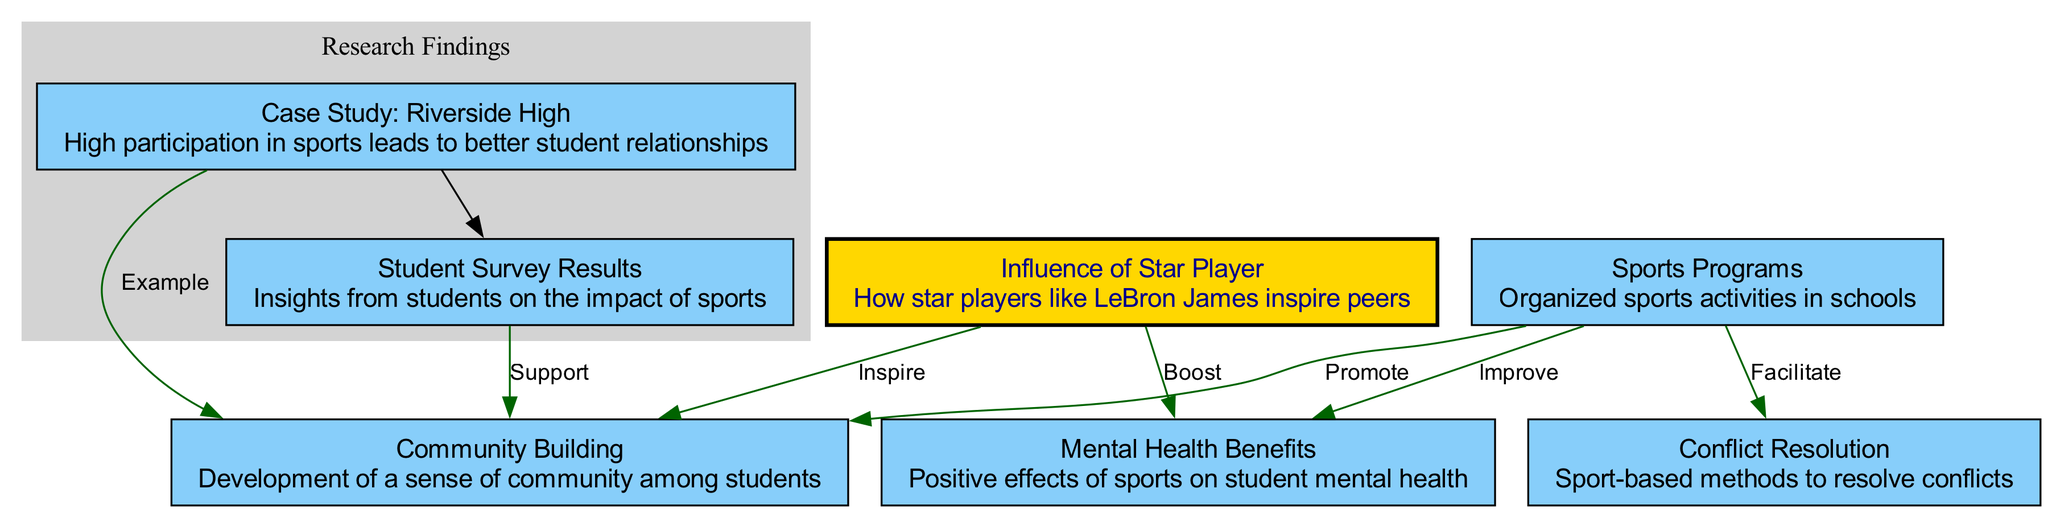What is one of the main benefits of sports programs in schools? Sports programs improve mental health among students, as indicated by the arrow connecting "Sports Programs" to "Mental Health Benefits" labeled "Improve."
Answer: Improve How does the case study of Riverside High relate to community building? The case study shows that high participation in sports at Riverside High serves as an example of promoting community building, as indicated by the direct connection labeled "Example."
Answer: Example What type of impact do student survey results have on community building? Student survey results support the development of community building, as shown by the edge labeled "Support" connecting "Student Survey Results" to "Community Building."
Answer: Support Which node highlights the influence of star players? The node labeled "Influence of Star Player" specifically focuses on how star players inspire their peers, indicating their role in community building and mental health.
Answer: Influence of Star Player How many edges are there connecting to the "Community Building" node? The "Community Building" node has three edges leading to it: from "Sports Programs," "Case Study: Riverside High," and "Student Survey Results," indicating its central role in the diagram.
Answer: Three In what ways do sports programs facilitate conflict resolution? Sports programs facilitate conflict resolution through sport-based methods, as illustrated by the directed edge labeled "Facilitate" connecting "Sports Programs" to "Conflict Resolution."
Answer: Facilitate What role does the influence of a star player play in mental health? The influence of a star player boosts mental health, as shown by the edge connecting "Influence of Star Player" to "Mental Health Benefits," labeled "Boost."
Answer: Boost What overarching theme does the diagram illustrate about sports in education? The overarching theme of the diagram is the role of sports in promoting social cohesion within educational institutions, driving multiple benefits such as community building, conflict resolution, and mental health improvement.
Answer: Social cohesion 